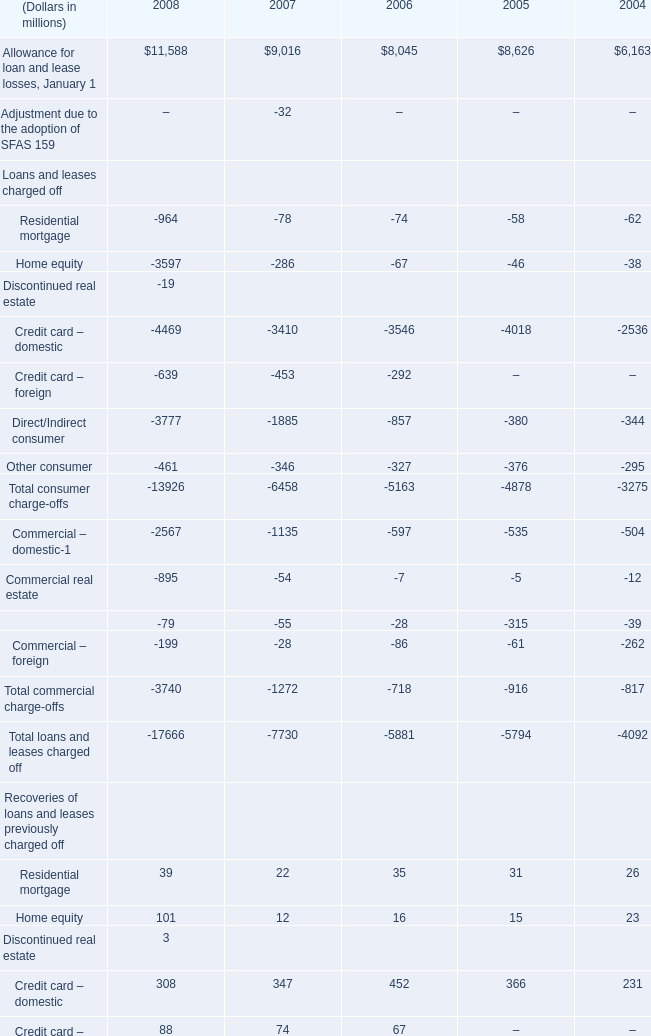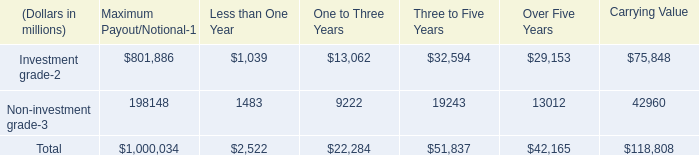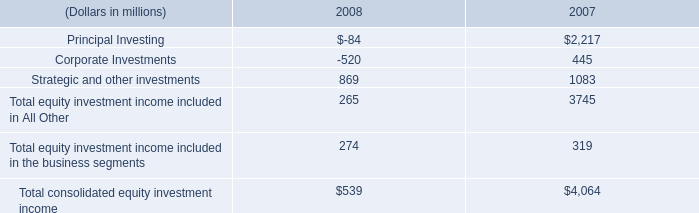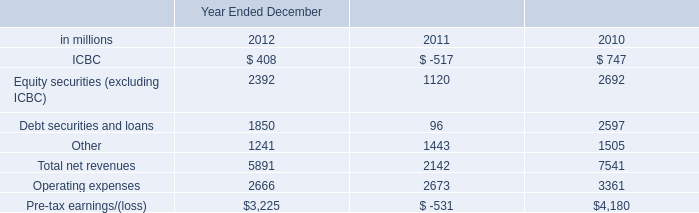What's the average of Allowance for loan and lease losses, January 1 in 2008 and 2007? (in millions) 
Computations: ((11588 + 9016) / 2)
Answer: 10302.0. 